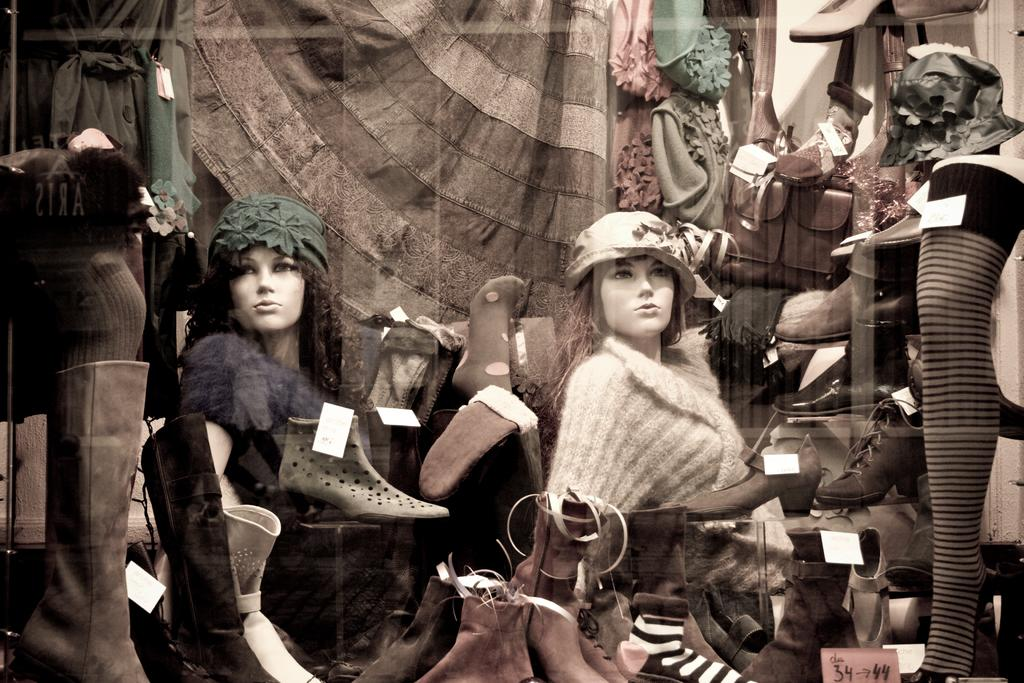What type of objects are present in the image? There are mannequins, shoes, bags, and garments in the image. Can you describe the mannequins in the image? The mannequins are likely used for displaying clothing or accessories. What items can be seen on the mannequins? The mannequins are wearing shoes and garments in the image. What other objects are related to fashion or clothing in the image? There are bags in the image, which could be used for carrying personal items or as fashion accessories. Are there any signs of destruction or cobwebs in the image? There is no indication of destruction or cobwebs in the image; it appears to be a clean and organized display of fashion items. 